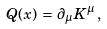<formula> <loc_0><loc_0><loc_500><loc_500>\, Q ( x ) \, = \, \partial _ { \mu } K ^ { \mu } \, ,</formula> 